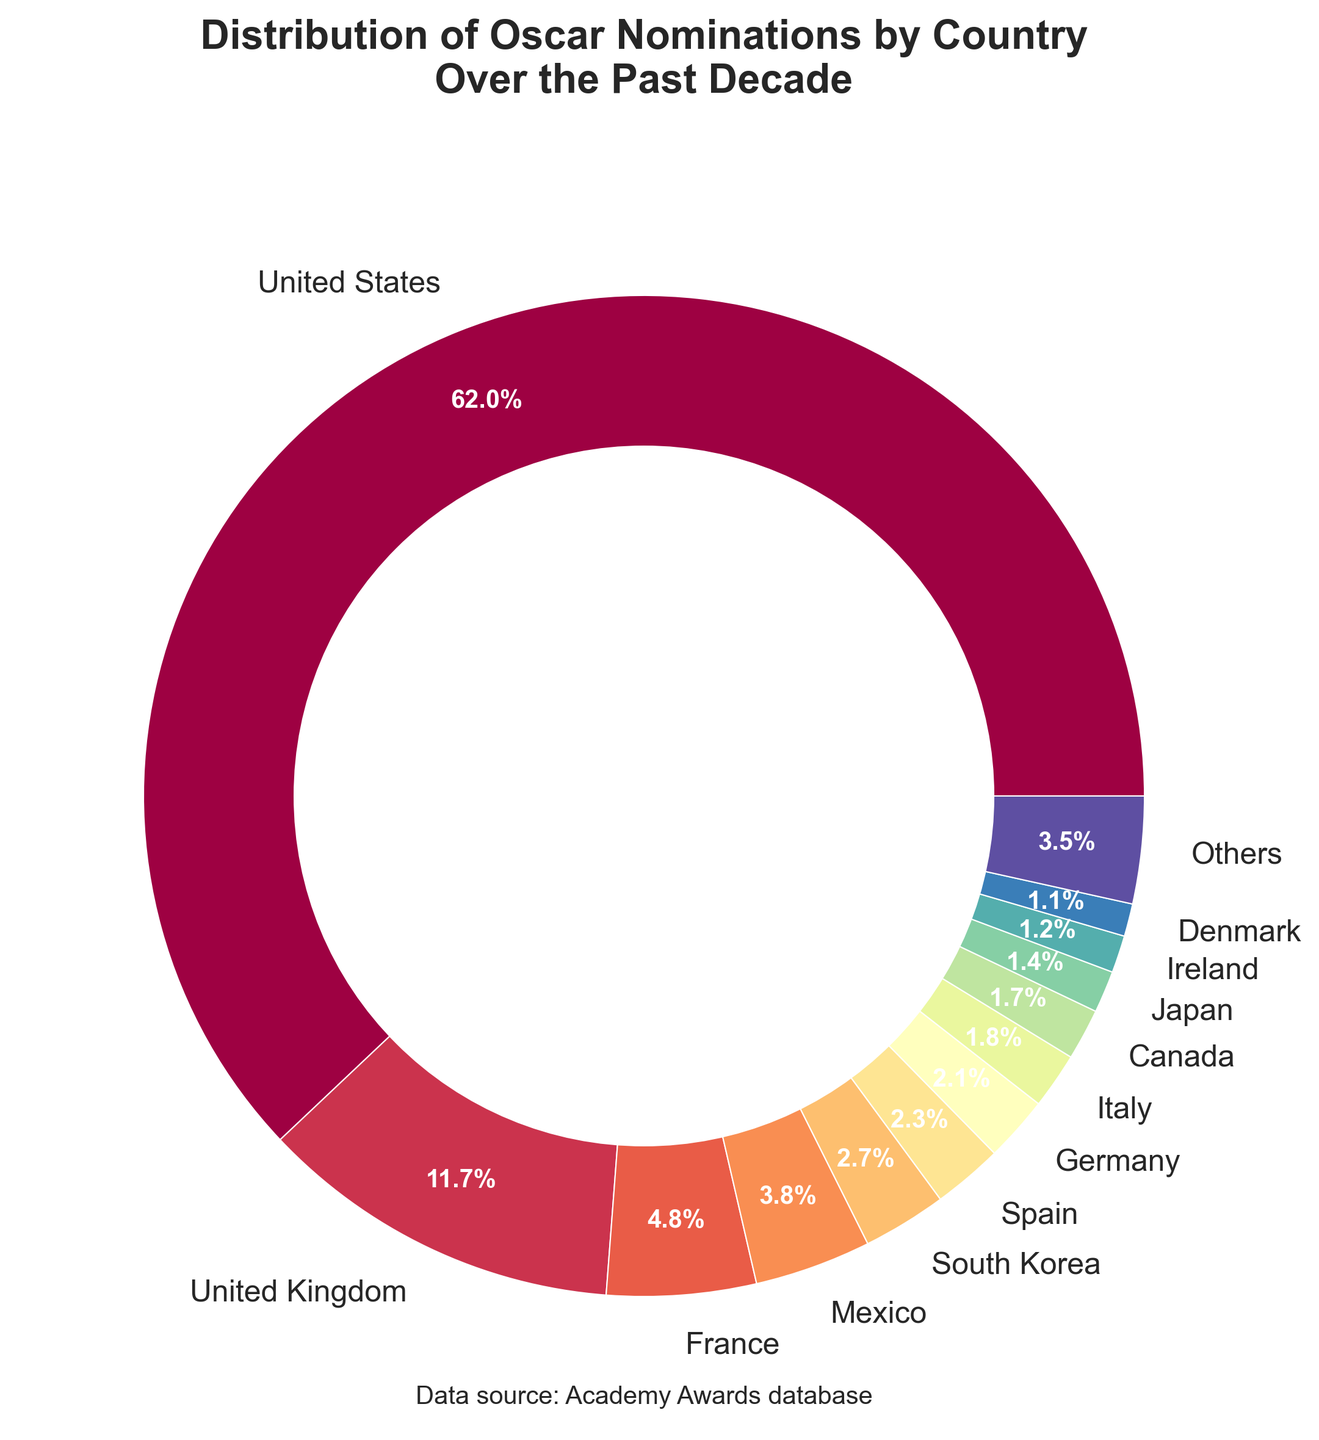Which country has the highest number of Oscar nominations? The United States is shown to have the largest segment in the pie chart.
Answer: The United States Which country has the smallest percentage of nominations represented in the chart? The Netherlands has the smallest segment shown.
Answer: The Netherlands What is the combined percentage of nominations for Spain and Germany? Spain has 15 nominations and Germany has 14 nominations. Combined, they have 29 nominations. The total nominations are 704. So, (29/704) * 100 ≈ 4.1%
Answer: 4.1% How many countries have received more than 10% of the total nominations? Only the United States has a segment that exceeds 10% of the entire pie chart.
Answer: 1 Compare the number of nominations received by Italy versus France. Which one has more? France has 32 nominations, while Italy has 12. Therefore, France has more nominations.
Answer: France Which color represents the United Kingdom? The United Kingdom is usually highlighted separately and distinctly, identifiable by its position and sizeable segment in the pie chart.
Answer: (Assuming the factual color from the chart, if mentioned) What proportion of nominations does "Others" group represent? Add the number of nominations for countries under 1% nomination each and calculate their proportion relative to the total (704). Sum up the nominations for Belgium, Brazil, Argentina, Netherlands which is 8. Then calculate (8/704) * 100.
Answer: 1.1% Which countries have roughly the same percentage of Oscar nominations? By visually comparing the sizes of segments, Germany (14 nominations) and Italy (12 nominations) have almost similar sizes.
Answer: Germany and Italy Between South Korea and Mexico, which country received fewer nominations? South Korea is indicated by a smaller segment compared to Mexico.
Answer: South Korea How many nominations do the top three countries combined have? The top three countries are the United States (412), the United Kingdom (78), and France (32). Adding these up, 412 + 78 + 32 = 522.
Answer: 522 